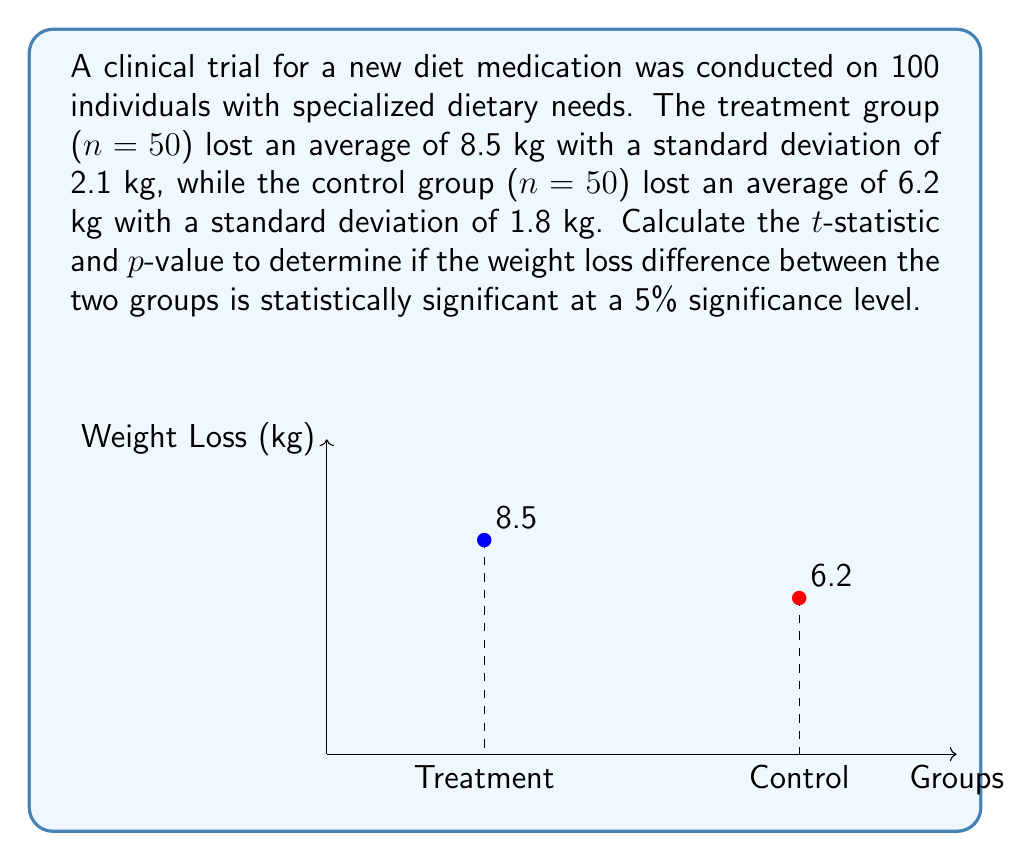Could you help me with this problem? To determine the statistical significance, we'll calculate the t-statistic and p-value:

1. Calculate the pooled standard deviation:
   $$s_p = \sqrt{\frac{(n_1 - 1)s_1^2 + (n_2 - 1)s_2^2}{n_1 + n_2 - 2}}$$
   $$s_p = \sqrt{\frac{(50 - 1)(2.1)^2 + (50 - 1)(1.8)^2}{50 + 50 - 2}} = 1.957$$

2. Calculate the standard error of the difference:
   $$SE = s_p \sqrt{\frac{1}{n_1} + \frac{1}{n_2}} = 1.957 \sqrt{\frac{1}{50} + \frac{1}{50}} = 0.391$$

3. Calculate the t-statistic:
   $$t = \frac{\bar{x}_1 - \bar{x}_2}{SE} = \frac{8.5 - 6.2}{0.391} = 5.88$$

4. Determine the degrees of freedom:
   $$df = n_1 + n_2 - 2 = 50 + 50 - 2 = 98$$

5. Find the critical t-value for a two-tailed test at 5% significance level:
   $$t_{critical} = \pm 1.984 \text{ (from t-distribution table)}$$

6. Calculate the p-value:
   The p-value for t = 5.88 with 98 degrees of freedom is less than 0.0001.

Since $|t| > t_{critical}$ and p-value < 0.05, we conclude that the difference in weight loss between the treatment and control groups is statistically significant at the 5% level.
Answer: t-statistic = 5.88, p-value < 0.0001 